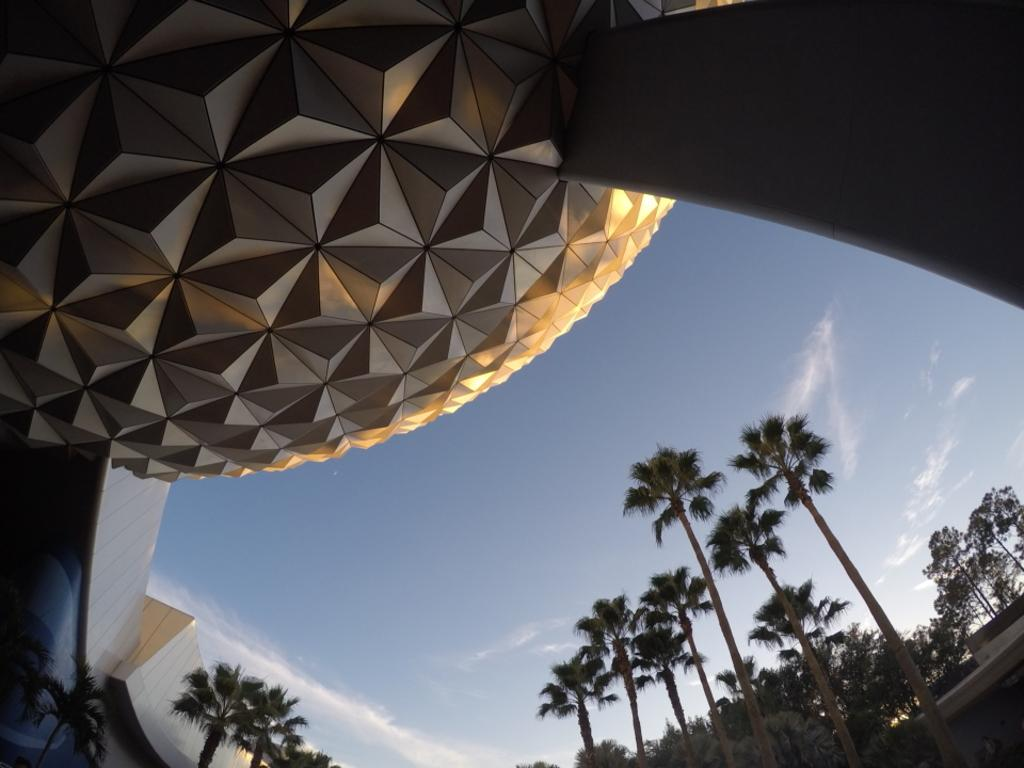What type of structure can be seen in the image? There is an architectural structure in the image. What other elements are present in the image besides the structure? There are trees in the image. What can be seen in the background of the image? The sky is visible in the background of the image. What is the condition of the sky in the image? Clouds are present in the sky. Reasoning: Let's think step by step by step in order to produce the conversation. We start by identifying the main subject in the image, which is the architectural structure. Then, we expand the conversation to include other elements that are also visible, such as trees and the sky. Each question is designed to elicit a specific detail about the image that is known from the provided facts. We avoid yes/no questions and ensure that the language is simple and clear. Absurd Question/Answer: How does the deer react to the surprise visitor in the image? There is no deer or visitor present in the image, so this question cannot be answered. How does the deer react to the surprise visitor in the image? There is no deer or visitor present in the image, so this question cannot be answered. 